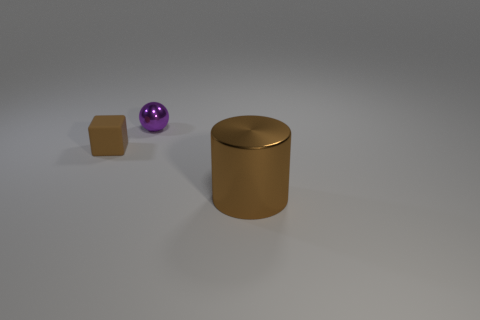Is there anything else that is the same size as the metallic cylinder?
Provide a succinct answer. No. Does the brown rubber thing have the same shape as the shiny object that is in front of the matte block?
Keep it short and to the point. No. There is a brown thing behind the shiny object in front of the tiny brown matte cube; what is its size?
Offer a terse response. Small. Is the number of brown matte cubes that are on the right side of the brown cube the same as the number of shiny cylinders that are on the left side of the brown shiny cylinder?
Offer a very short reply. Yes. What number of tiny shiny things are the same color as the large metallic thing?
Provide a short and direct response. 0. Do the tiny object that is in front of the purple thing and the large object have the same shape?
Your response must be concise. No. There is a thing that is right of the metallic object left of the brown thing on the right side of the purple shiny thing; what shape is it?
Provide a short and direct response. Cylinder. What size is the purple thing?
Make the answer very short. Small. What color is the other thing that is the same material as the purple object?
Your response must be concise. Brown. What number of other big brown cylinders are the same material as the big cylinder?
Provide a short and direct response. 0. 